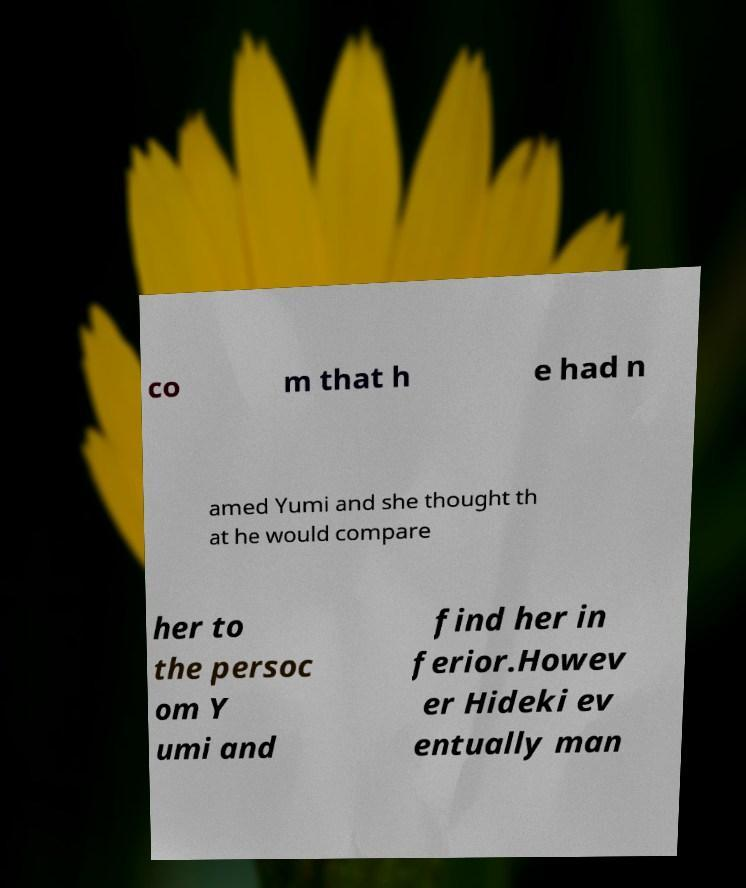Can you accurately transcribe the text from the provided image for me? co m that h e had n amed Yumi and she thought th at he would compare her to the persoc om Y umi and find her in ferior.Howev er Hideki ev entually man 